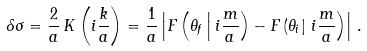Convert formula to latex. <formula><loc_0><loc_0><loc_500><loc_500>\delta \sigma = \frac { 2 } { a } \, K \left ( i \frac { k } { a } \right ) = \frac { 1 } { a } \left | F \left ( \theta _ { f } \left | \, i \frac { m } { a } \right ) - F \left ( \theta _ { i } \right | \, i \frac { m } { a } \right ) \right | \, .</formula> 